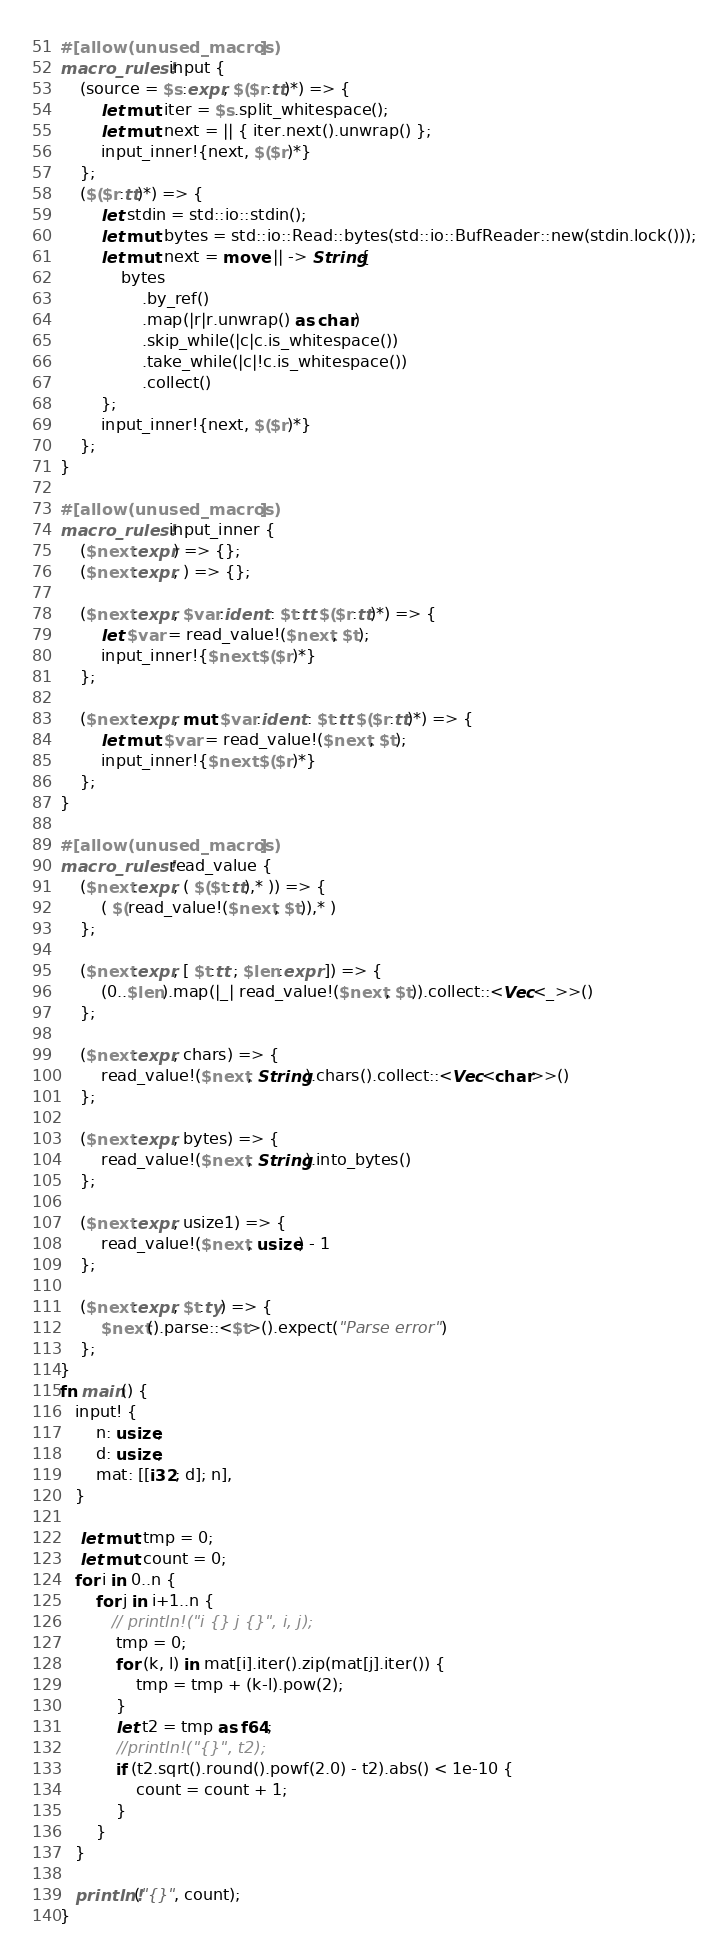Convert code to text. <code><loc_0><loc_0><loc_500><loc_500><_Rust_>#[allow(unused_macros)]
macro_rules! input {
    (source = $s:expr, $($r:tt)*) => {
        let mut iter = $s.split_whitespace();
        let mut next = || { iter.next().unwrap() };
        input_inner!{next, $($r)*}
    };
    ($($r:tt)*) => {
        let stdin = std::io::stdin();
        let mut bytes = std::io::Read::bytes(std::io::BufReader::new(stdin.lock()));
        let mut next = move || -> String{
            bytes
                .by_ref()
                .map(|r|r.unwrap() as char)
                .skip_while(|c|c.is_whitespace())
                .take_while(|c|!c.is_whitespace())
                .collect()
        };
        input_inner!{next, $($r)*}
    };
}
 
#[allow(unused_macros)]
macro_rules! input_inner {
    ($next:expr) => {};
    ($next:expr, ) => {};
 
    ($next:expr, $var:ident : $t:tt $($r:tt)*) => {
        let $var = read_value!($next, $t);
        input_inner!{$next $($r)*}
    };
 
    ($next:expr, mut $var:ident : $t:tt $($r:tt)*) => {
        let mut $var = read_value!($next, $t);
        input_inner!{$next $($r)*}
    };
}
 
#[allow(unused_macros)]
macro_rules! read_value {
    ($next:expr, ( $($t:tt),* )) => {
        ( $(read_value!($next, $t)),* )
    };
 
    ($next:expr, [ $t:tt ; $len:expr ]) => {
        (0..$len).map(|_| read_value!($next, $t)).collect::<Vec<_>>()
    };
 
    ($next:expr, chars) => {
        read_value!($next, String).chars().collect::<Vec<char>>()
    };
 
    ($next:expr, bytes) => {
        read_value!($next, String).into_bytes()
    };
 
    ($next:expr, usize1) => {
        read_value!($next, usize) - 1
    };
 
    ($next:expr, $t:ty) => {
        $next().parse::<$t>().expect("Parse error")
    };
}
fn main() {
   input! {
       n: usize,
       d: usize,
       mat: [[i32; d]; n],
   } 

    let mut tmp = 0;
    let mut count = 0;
   for i in 0..n {
       for j in i+1..n {
          // println!("i {} j {}", i, j);
           tmp = 0;
           for (k, l) in mat[i].iter().zip(mat[j].iter()) {
               tmp = tmp + (k-l).pow(2);
           }
           let t2 = tmp as f64;
           //println!("{}", t2);
           if (t2.sqrt().round().powf(2.0) - t2).abs() < 1e-10 {
               count = count + 1;
           }
       }
   }

   println!("{}", count);
}</code> 